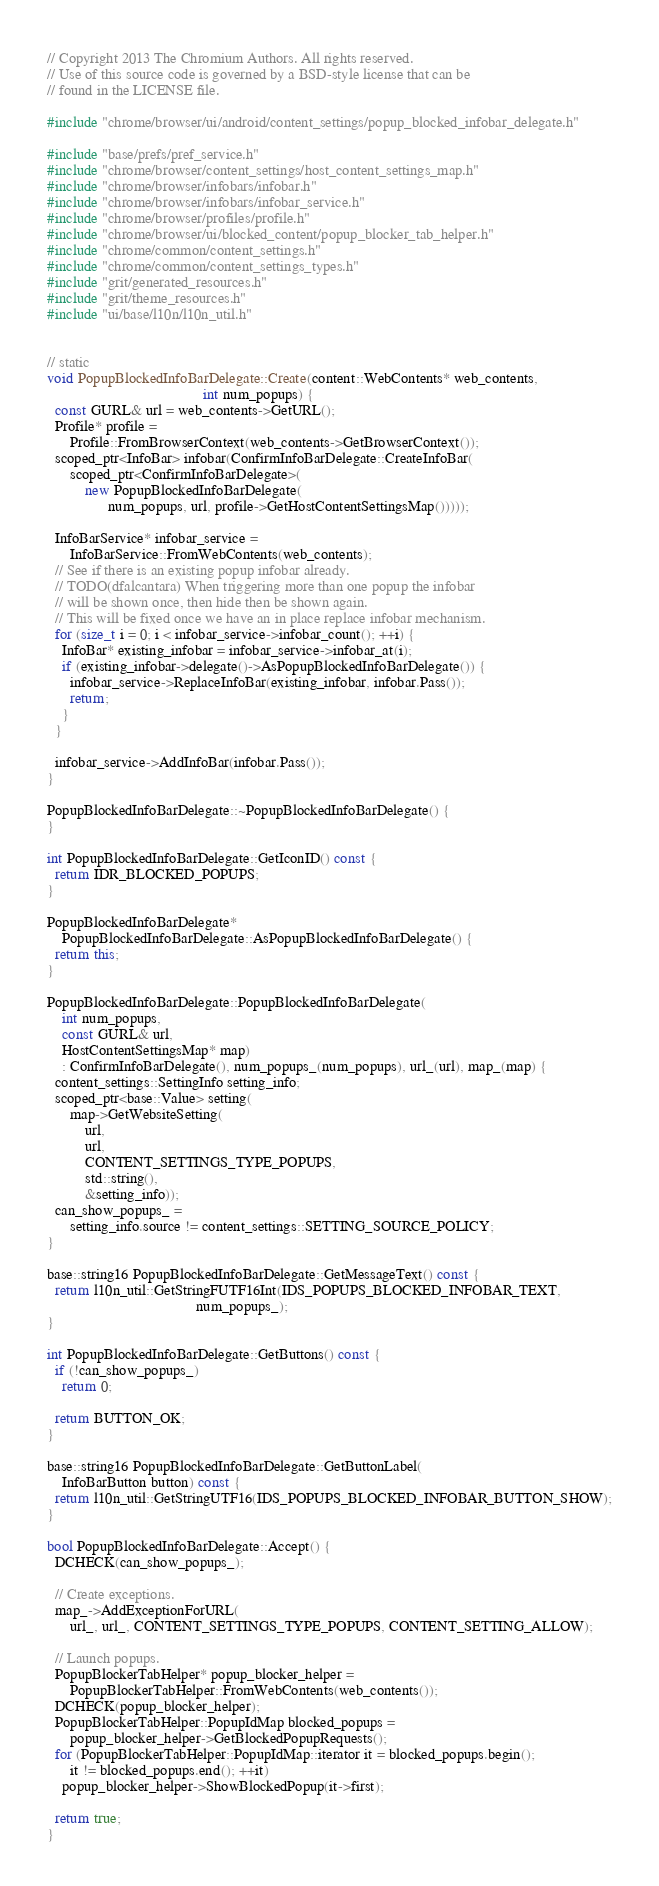<code> <loc_0><loc_0><loc_500><loc_500><_C++_>// Copyright 2013 The Chromium Authors. All rights reserved.
// Use of this source code is governed by a BSD-style license that can be
// found in the LICENSE file.

#include "chrome/browser/ui/android/content_settings/popup_blocked_infobar_delegate.h"

#include "base/prefs/pref_service.h"
#include "chrome/browser/content_settings/host_content_settings_map.h"
#include "chrome/browser/infobars/infobar.h"
#include "chrome/browser/infobars/infobar_service.h"
#include "chrome/browser/profiles/profile.h"
#include "chrome/browser/ui/blocked_content/popup_blocker_tab_helper.h"
#include "chrome/common/content_settings.h"
#include "chrome/common/content_settings_types.h"
#include "grit/generated_resources.h"
#include "grit/theme_resources.h"
#include "ui/base/l10n/l10n_util.h"


// static
void PopupBlockedInfoBarDelegate::Create(content::WebContents* web_contents,
                                         int num_popups) {
  const GURL& url = web_contents->GetURL();
  Profile* profile =
      Profile::FromBrowserContext(web_contents->GetBrowserContext());
  scoped_ptr<InfoBar> infobar(ConfirmInfoBarDelegate::CreateInfoBar(
      scoped_ptr<ConfirmInfoBarDelegate>(
          new PopupBlockedInfoBarDelegate(
                num_popups, url, profile->GetHostContentSettingsMap()))));

  InfoBarService* infobar_service =
      InfoBarService::FromWebContents(web_contents);
  // See if there is an existing popup infobar already.
  // TODO(dfalcantara) When triggering more than one popup the infobar
  // will be shown once, then hide then be shown again.
  // This will be fixed once we have an in place replace infobar mechanism.
  for (size_t i = 0; i < infobar_service->infobar_count(); ++i) {
    InfoBar* existing_infobar = infobar_service->infobar_at(i);
    if (existing_infobar->delegate()->AsPopupBlockedInfoBarDelegate()) {
      infobar_service->ReplaceInfoBar(existing_infobar, infobar.Pass());
      return;
    }
  }

  infobar_service->AddInfoBar(infobar.Pass());
}

PopupBlockedInfoBarDelegate::~PopupBlockedInfoBarDelegate() {
}

int PopupBlockedInfoBarDelegate::GetIconID() const {
  return IDR_BLOCKED_POPUPS;
}

PopupBlockedInfoBarDelegate*
    PopupBlockedInfoBarDelegate::AsPopupBlockedInfoBarDelegate() {
  return this;
}

PopupBlockedInfoBarDelegate::PopupBlockedInfoBarDelegate(
    int num_popups,
    const GURL& url,
    HostContentSettingsMap* map)
    : ConfirmInfoBarDelegate(), num_popups_(num_popups), url_(url), map_(map) {
  content_settings::SettingInfo setting_info;
  scoped_ptr<base::Value> setting(
      map->GetWebsiteSetting(
          url,
          url,
          CONTENT_SETTINGS_TYPE_POPUPS,
          std::string(),
          &setting_info));
  can_show_popups_ =
      setting_info.source != content_settings::SETTING_SOURCE_POLICY;
}

base::string16 PopupBlockedInfoBarDelegate::GetMessageText() const {
  return l10n_util::GetStringFUTF16Int(IDS_POPUPS_BLOCKED_INFOBAR_TEXT,
                                       num_popups_);
}

int PopupBlockedInfoBarDelegate::GetButtons() const {
  if (!can_show_popups_)
    return 0;

  return BUTTON_OK;
}

base::string16 PopupBlockedInfoBarDelegate::GetButtonLabel(
    InfoBarButton button) const {
  return l10n_util::GetStringUTF16(IDS_POPUPS_BLOCKED_INFOBAR_BUTTON_SHOW);
}

bool PopupBlockedInfoBarDelegate::Accept() {
  DCHECK(can_show_popups_);

  // Create exceptions.
  map_->AddExceptionForURL(
      url_, url_, CONTENT_SETTINGS_TYPE_POPUPS, CONTENT_SETTING_ALLOW);

  // Launch popups.
  PopupBlockerTabHelper* popup_blocker_helper =
      PopupBlockerTabHelper::FromWebContents(web_contents());
  DCHECK(popup_blocker_helper);
  PopupBlockerTabHelper::PopupIdMap blocked_popups =
      popup_blocker_helper->GetBlockedPopupRequests();
  for (PopupBlockerTabHelper::PopupIdMap::iterator it = blocked_popups.begin();
      it != blocked_popups.end(); ++it)
    popup_blocker_helper->ShowBlockedPopup(it->first);

  return true;
}

</code> 